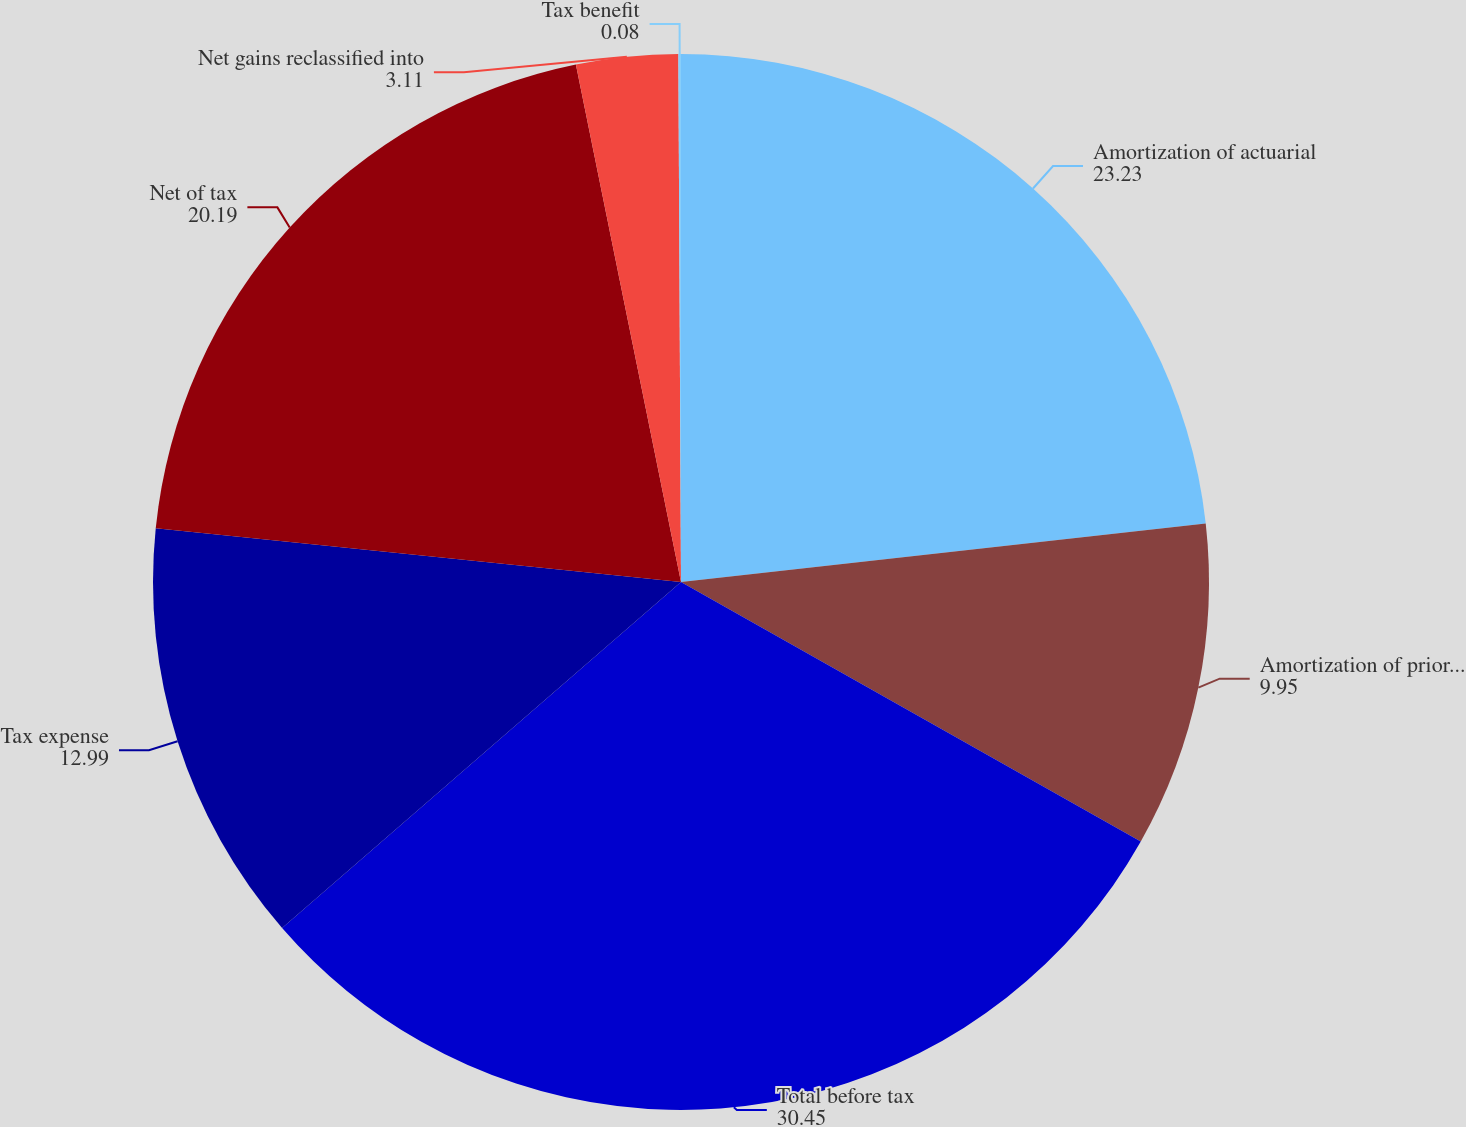Convert chart to OTSL. <chart><loc_0><loc_0><loc_500><loc_500><pie_chart><fcel>Amortization of actuarial<fcel>Amortization of prior service<fcel>Total before tax<fcel>Tax expense<fcel>Net of tax<fcel>Net gains reclassified into<fcel>Tax benefit<nl><fcel>23.23%<fcel>9.95%<fcel>30.45%<fcel>12.99%<fcel>20.19%<fcel>3.11%<fcel>0.08%<nl></chart> 